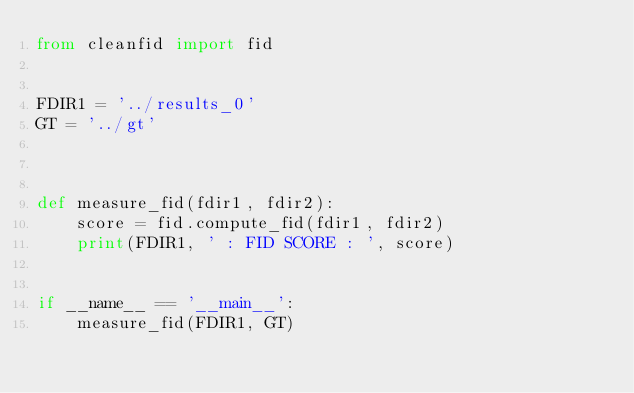<code> <loc_0><loc_0><loc_500><loc_500><_Python_>from cleanfid import fid


FDIR1 = '../results_0'
GT = '../gt'



def measure_fid(fdir1, fdir2):
    score = fid.compute_fid(fdir1, fdir2)
    print(FDIR1, ' : FID SCORE : ', score)


if __name__ == '__main__':
    measure_fid(FDIR1, GT)
</code> 